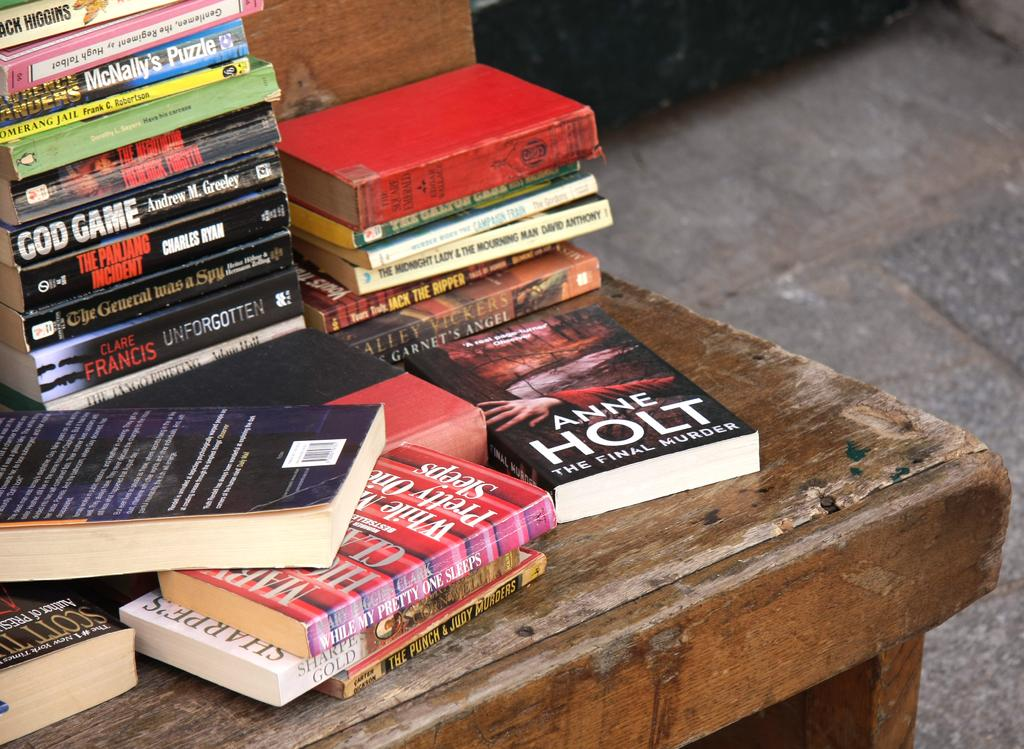<image>
Offer a succinct explanation of the picture presented. A book by Anne Holy is on a table with other books. 